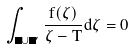Convert formula to latex. <formula><loc_0><loc_0><loc_500><loc_500>\int _ { \Gamma \cup \Omega ^ { \prime } } \frac { f ( \zeta ) } { \zeta - T } d \zeta = 0</formula> 